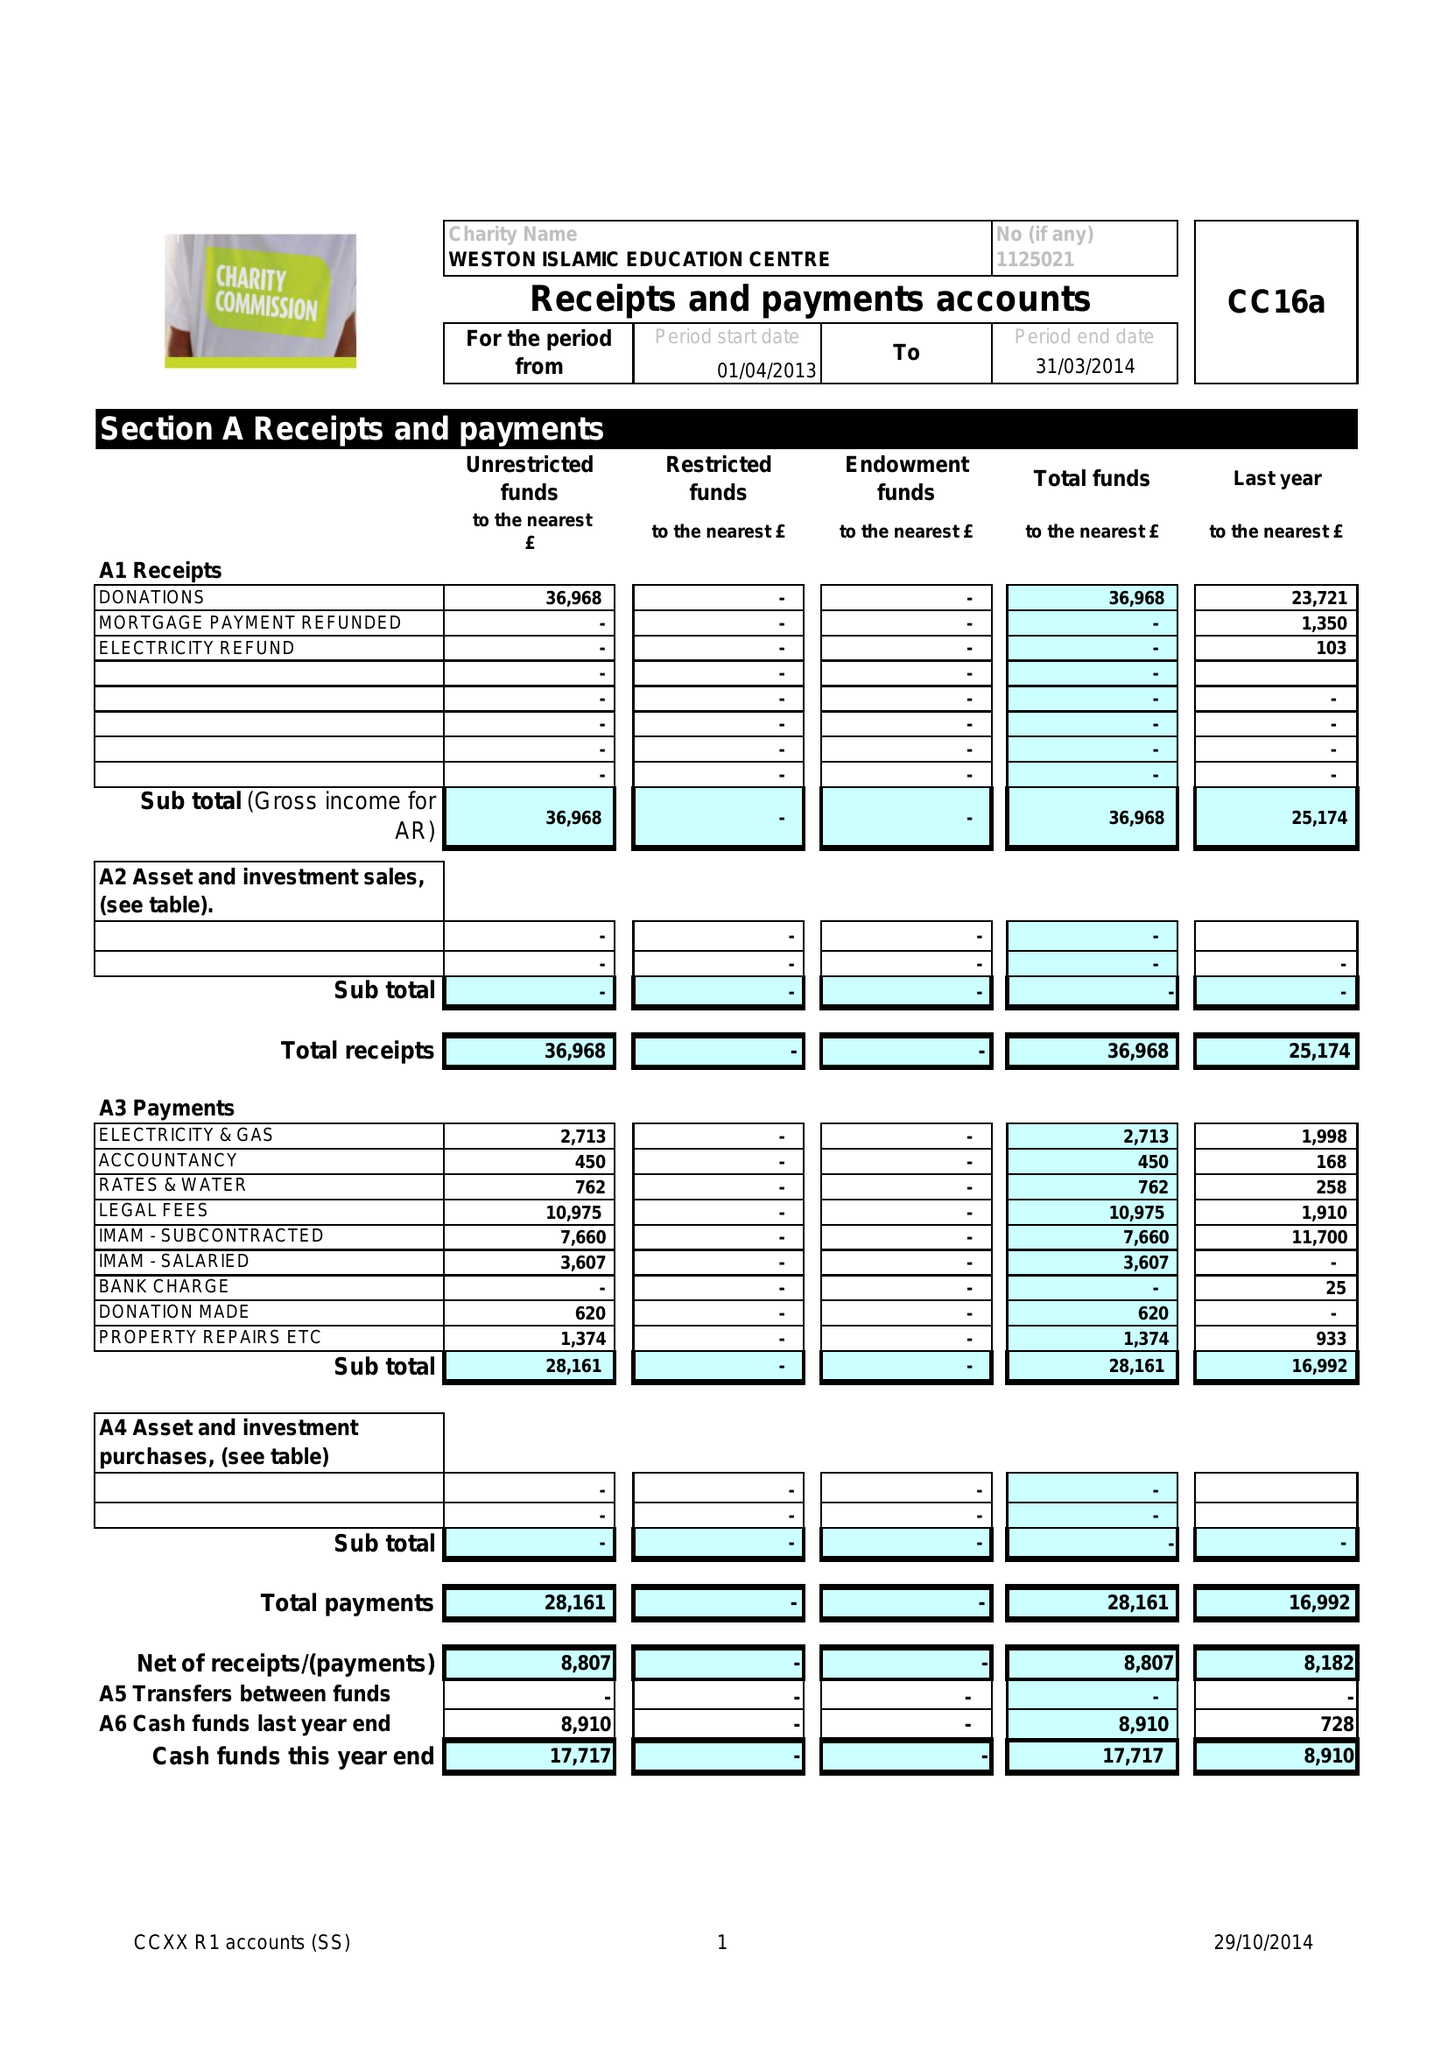What is the value for the charity_number?
Answer the question using a single word or phrase. 1125021 